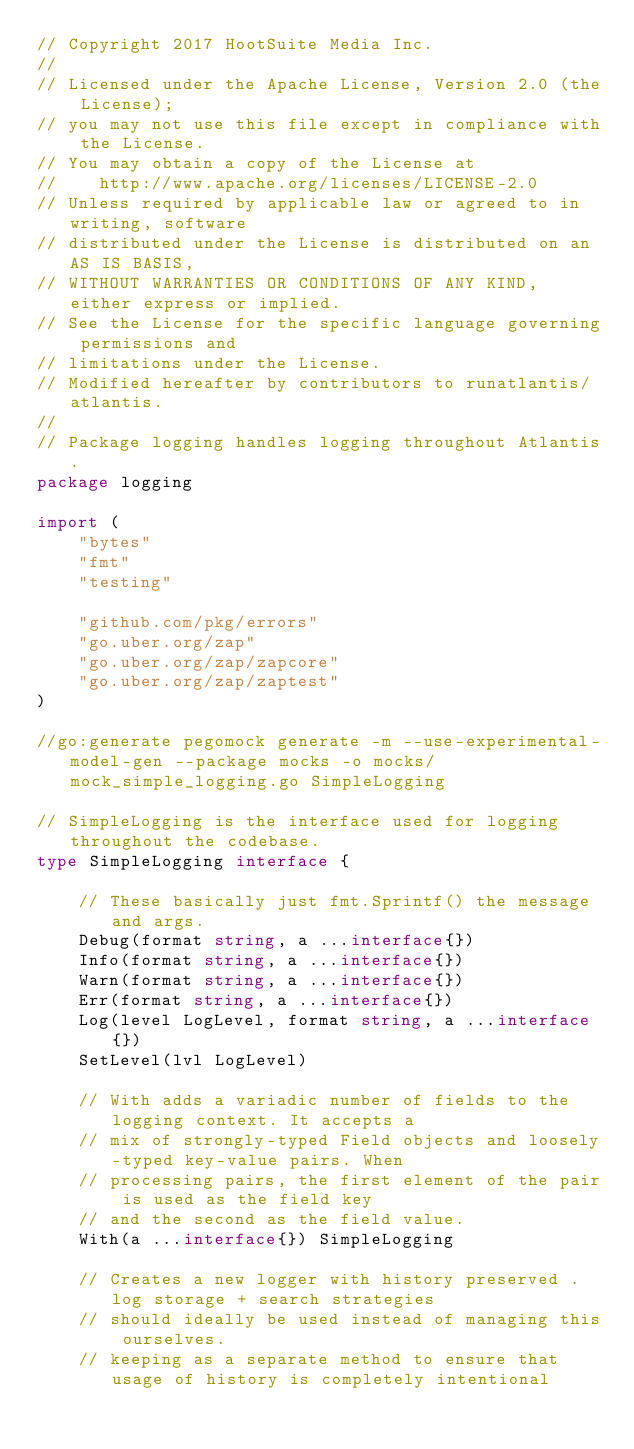<code> <loc_0><loc_0><loc_500><loc_500><_Go_>// Copyright 2017 HootSuite Media Inc.
//
// Licensed under the Apache License, Version 2.0 (the License);
// you may not use this file except in compliance with the License.
// You may obtain a copy of the License at
//    http://www.apache.org/licenses/LICENSE-2.0
// Unless required by applicable law or agreed to in writing, software
// distributed under the License is distributed on an AS IS BASIS,
// WITHOUT WARRANTIES OR CONDITIONS OF ANY KIND, either express or implied.
// See the License for the specific language governing permissions and
// limitations under the License.
// Modified hereafter by contributors to runatlantis/atlantis.
//
// Package logging handles logging throughout Atlantis.
package logging

import (
	"bytes"
	"fmt"
	"testing"

	"github.com/pkg/errors"
	"go.uber.org/zap"
	"go.uber.org/zap/zapcore"
	"go.uber.org/zap/zaptest"
)

//go:generate pegomock generate -m --use-experimental-model-gen --package mocks -o mocks/mock_simple_logging.go SimpleLogging

// SimpleLogging is the interface used for logging throughout the codebase.
type SimpleLogging interface {

	// These basically just fmt.Sprintf() the message and args.
	Debug(format string, a ...interface{})
	Info(format string, a ...interface{})
	Warn(format string, a ...interface{})
	Err(format string, a ...interface{})
	Log(level LogLevel, format string, a ...interface{})
	SetLevel(lvl LogLevel)

	// With adds a variadic number of fields to the logging context. It accepts a
	// mix of strongly-typed Field objects and loosely-typed key-value pairs. When
	// processing pairs, the first element of the pair is used as the field key
	// and the second as the field value.
	With(a ...interface{}) SimpleLogging

	// Creates a new logger with history preserved . log storage + search strategies
	// should ideally be used instead of managing this ourselves.
	// keeping as a separate method to ensure that usage of history is completely intentional</code> 